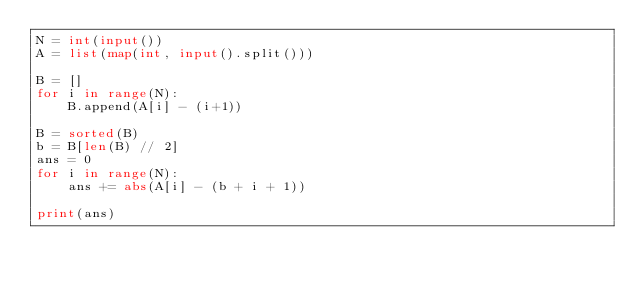Convert code to text. <code><loc_0><loc_0><loc_500><loc_500><_Python_>N = int(input())
A = list(map(int, input().split()))

B = []
for i in range(N):
    B.append(A[i] - (i+1))
    
B = sorted(B)
b = B[len(B) // 2]
ans = 0
for i in range(N):
    ans += abs(A[i] - (b + i + 1))

print(ans)</code> 